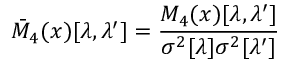<formula> <loc_0><loc_0><loc_500><loc_500>\bar { M } _ { 4 } ( x ) [ \lambda , \lambda ^ { \prime } ] = \frac { M _ { 4 } ( x ) [ \lambda , \lambda ^ { \prime } ] } { \sigma ^ { 2 } [ \lambda ] \sigma ^ { 2 } [ \lambda ^ { \prime } ] }</formula> 